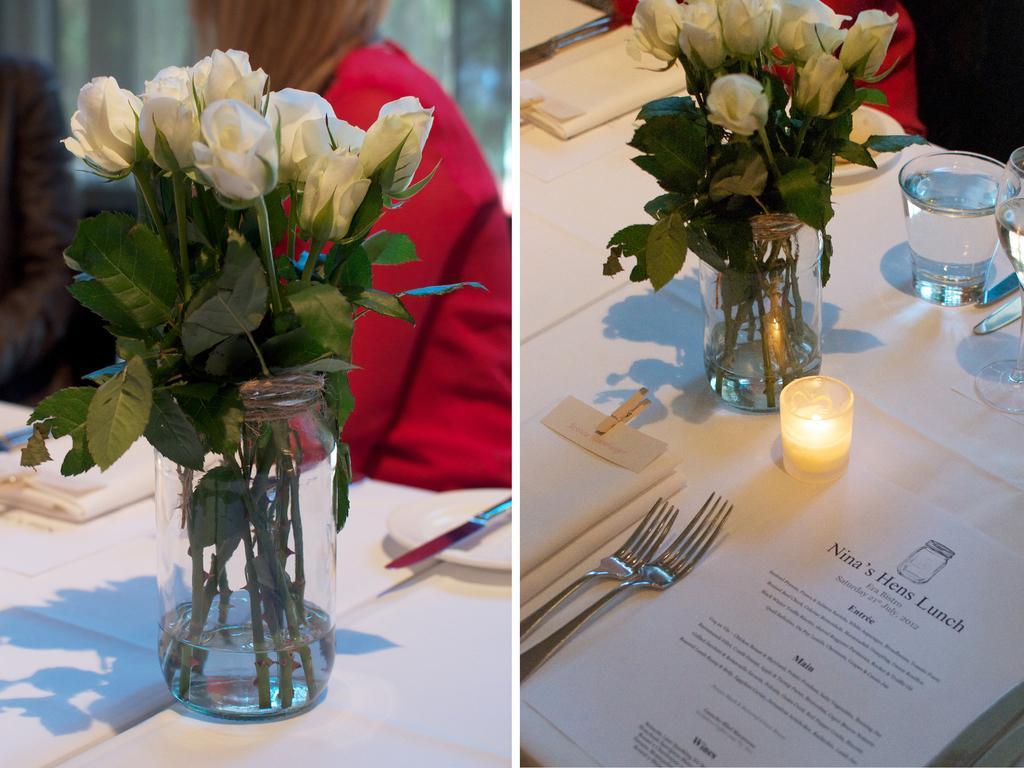Describe this image in one or two sentences. This looks like an edited image. These are the bunch of white rose flowers which are kept inside the glass jar. This is the table covered with white cloth. These are forks,napkins,candle,water glass,paper placed on the table. Here is the women wearing red dress. This is a knife and plate on the table. 